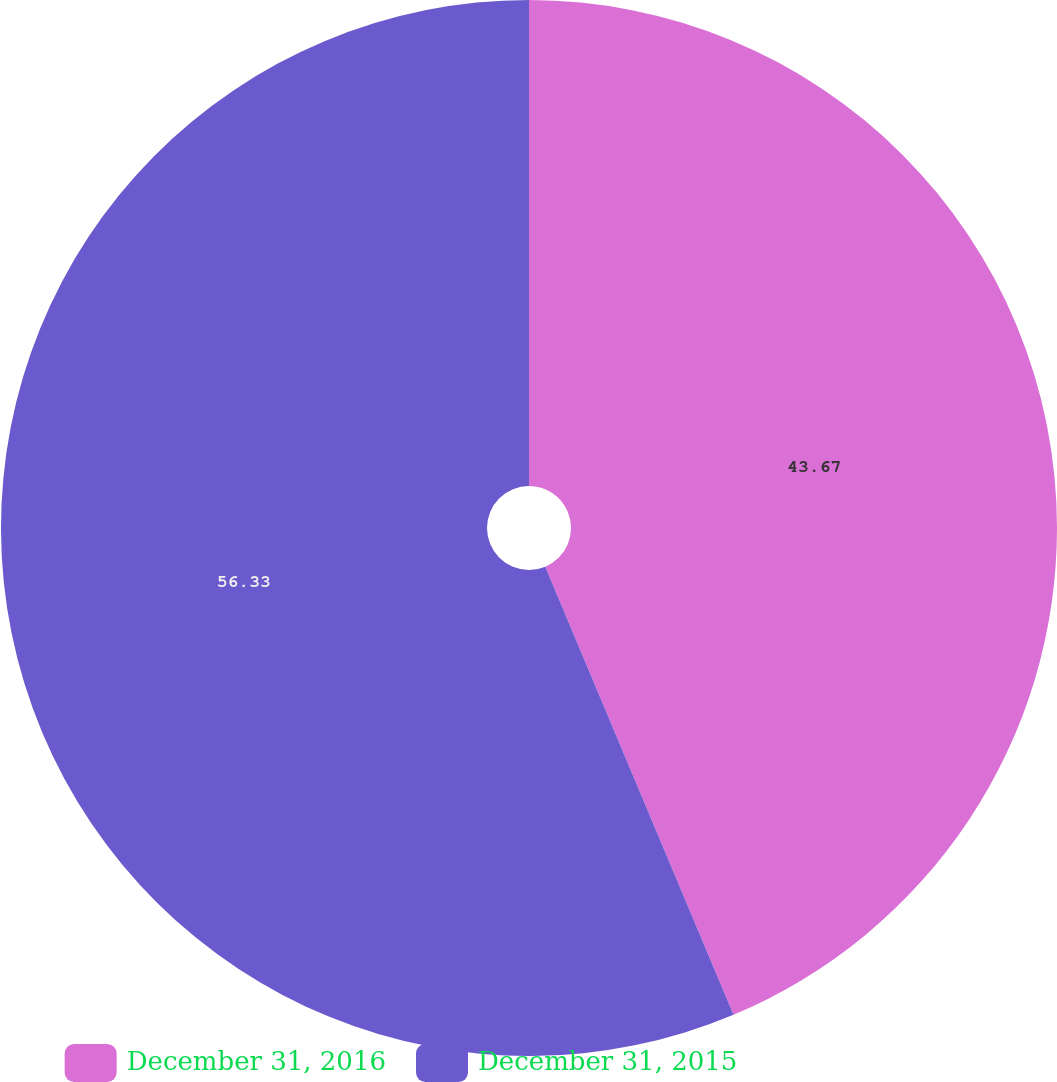Convert chart. <chart><loc_0><loc_0><loc_500><loc_500><pie_chart><fcel>December 31, 2016<fcel>December 31, 2015<nl><fcel>43.67%<fcel>56.33%<nl></chart> 